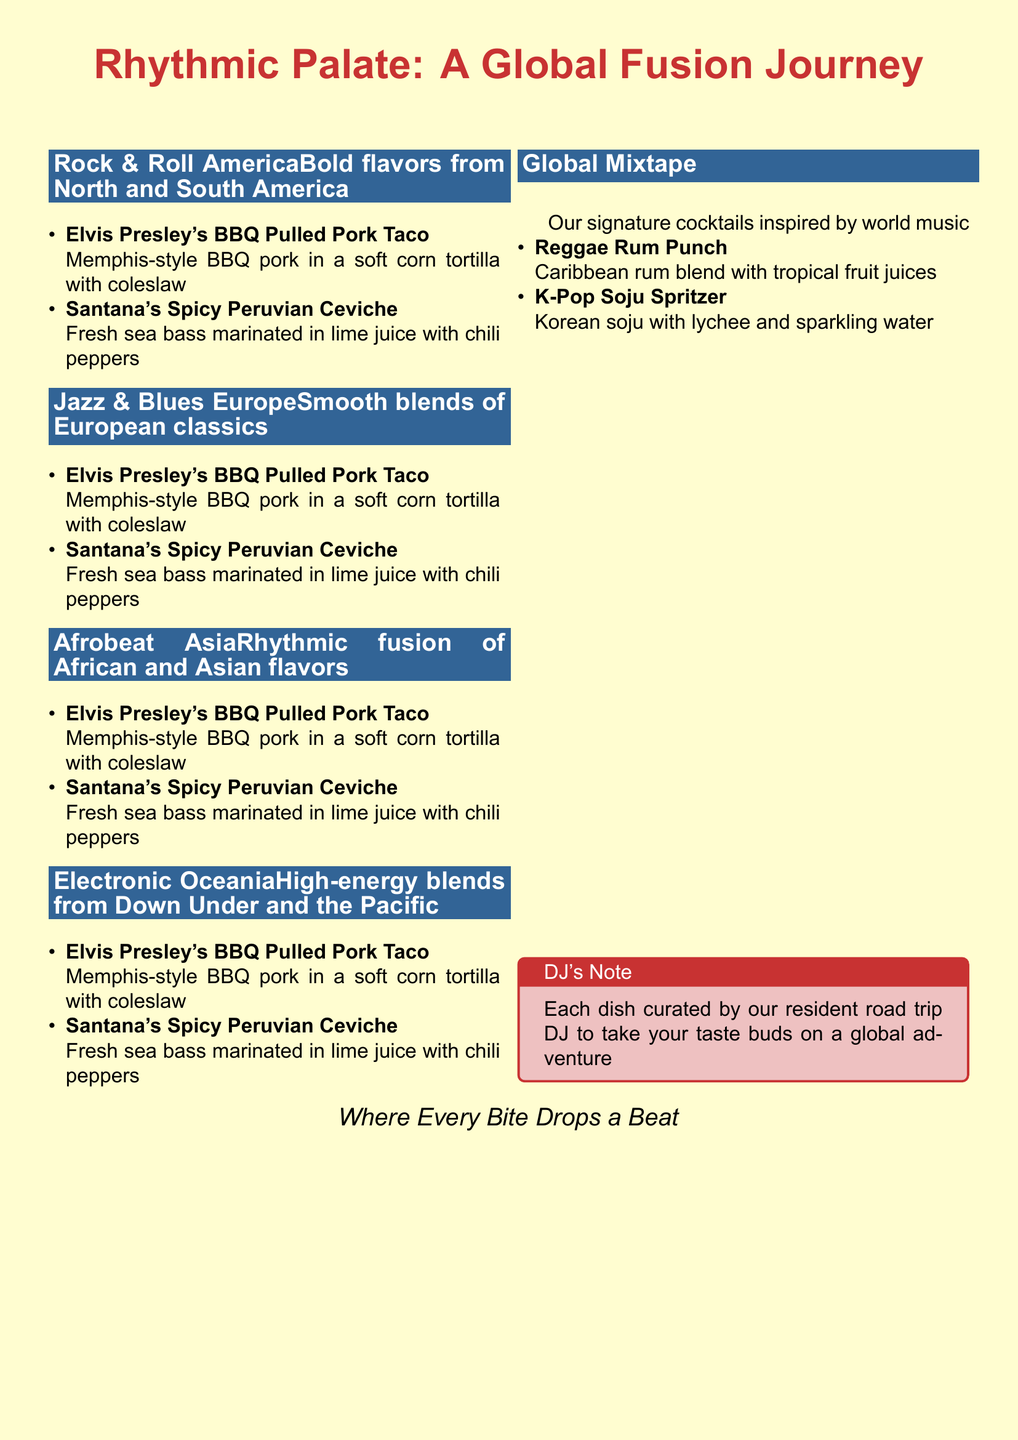What is the title of the menu? The title of the menu is prominently displayed at the top of the document, stating the theme of the restaurant.
Answer: Rhythmic Palate: A Global Fusion Journey How many sections are there in the menu? The menu features multiple sections, each one dedicated to a different music genre and its corresponding cuisine.
Answer: 4 What is served in the Rock & Roll America section? This section lists specific dishes that represent bold flavors from North and South America.
Answer: BBQ Pulled Pork Taco, Spicy Peruvian Ceviche What cocktail is inspired by K-Pop? The menu includes unique cocktails that reflect different global music influences, including one inspired by K-Pop.
Answer: K-Pop Soju Spritzer What color is used for the section headers? The document uses a specific color for the section headers that stands out against the background.
Answer: White Which cuisine is highlighted in the Afrobeat Asia section? This section combines flavors from two continents, focusing on specific culinary traditions.
Answer: African and Asian flavors What is the inspiration behind the Global Mixtape? This part of the menu is themed around signature drinks created from diverse cultural influences.
Answer: World music What type of dish is Elvis Presley’s BBQ Pulled Pork Taco? The document specifies what type of dish this is based on its preparation and presentation.
Answer: Taco What is a feature of the dishes curated by the DJ? The dishes are designed to evoke a sensory experience related to music, enhancing the dining experience.
Answer: Global adventure 